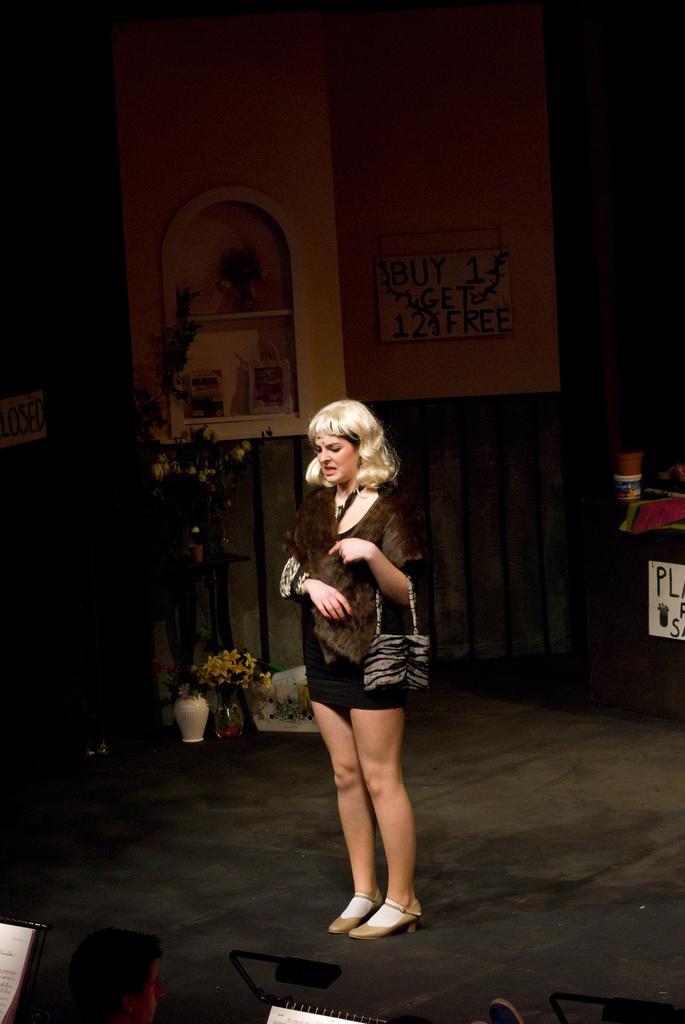Could you give a brief overview of what you see in this image? In this picture I can see a woman standing on the floor. I can see the plant vase on the left side. I can see the rack shelf. I can see wooden wall. 